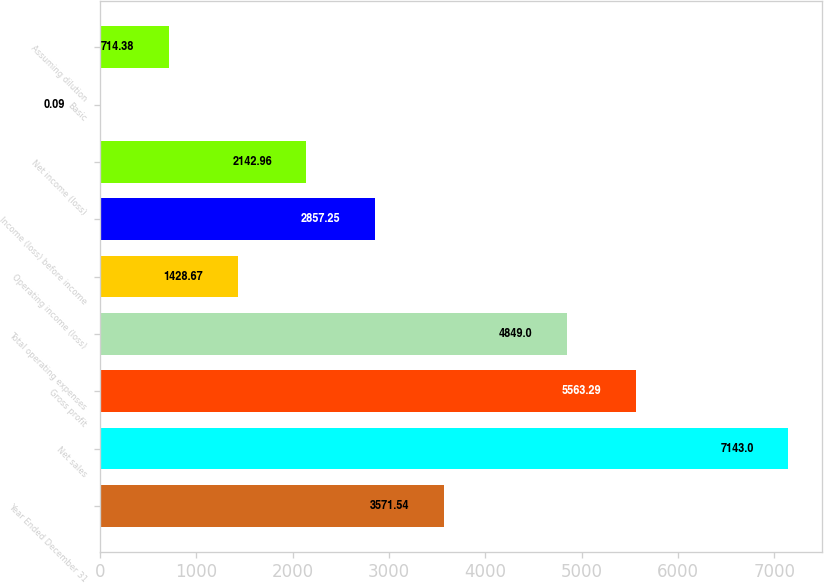<chart> <loc_0><loc_0><loc_500><loc_500><bar_chart><fcel>Year Ended December 31<fcel>Net sales<fcel>Gross profit<fcel>Total operating expenses<fcel>Operating income (loss)<fcel>Income (loss) before income<fcel>Net income (loss)<fcel>Basic<fcel>Assuming dilution<nl><fcel>3571.54<fcel>7143<fcel>5563.29<fcel>4849<fcel>1428.67<fcel>2857.25<fcel>2142.96<fcel>0.09<fcel>714.38<nl></chart> 